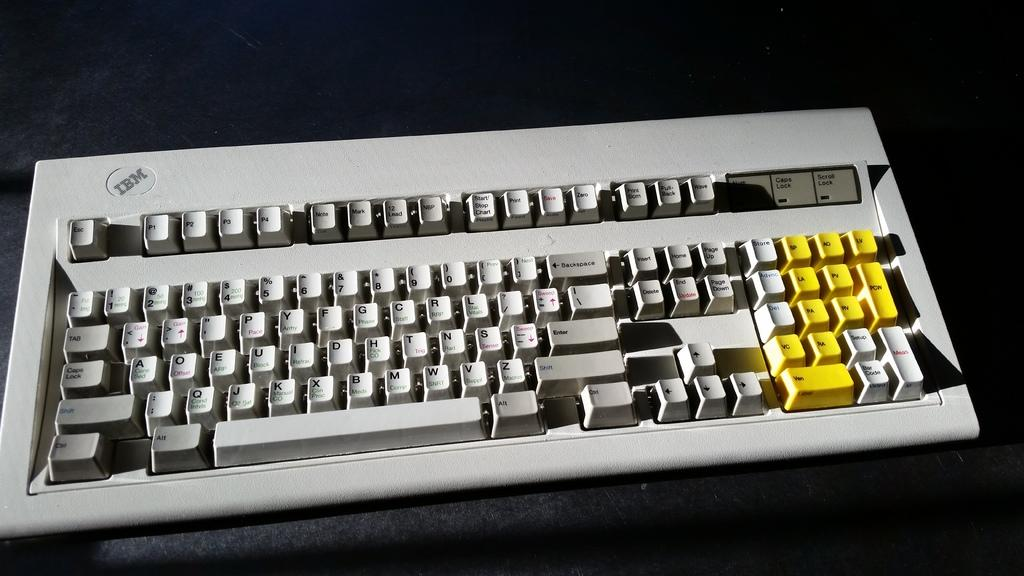<image>
Create a compact narrative representing the image presented. The old gray keyboard is from the company IBM 